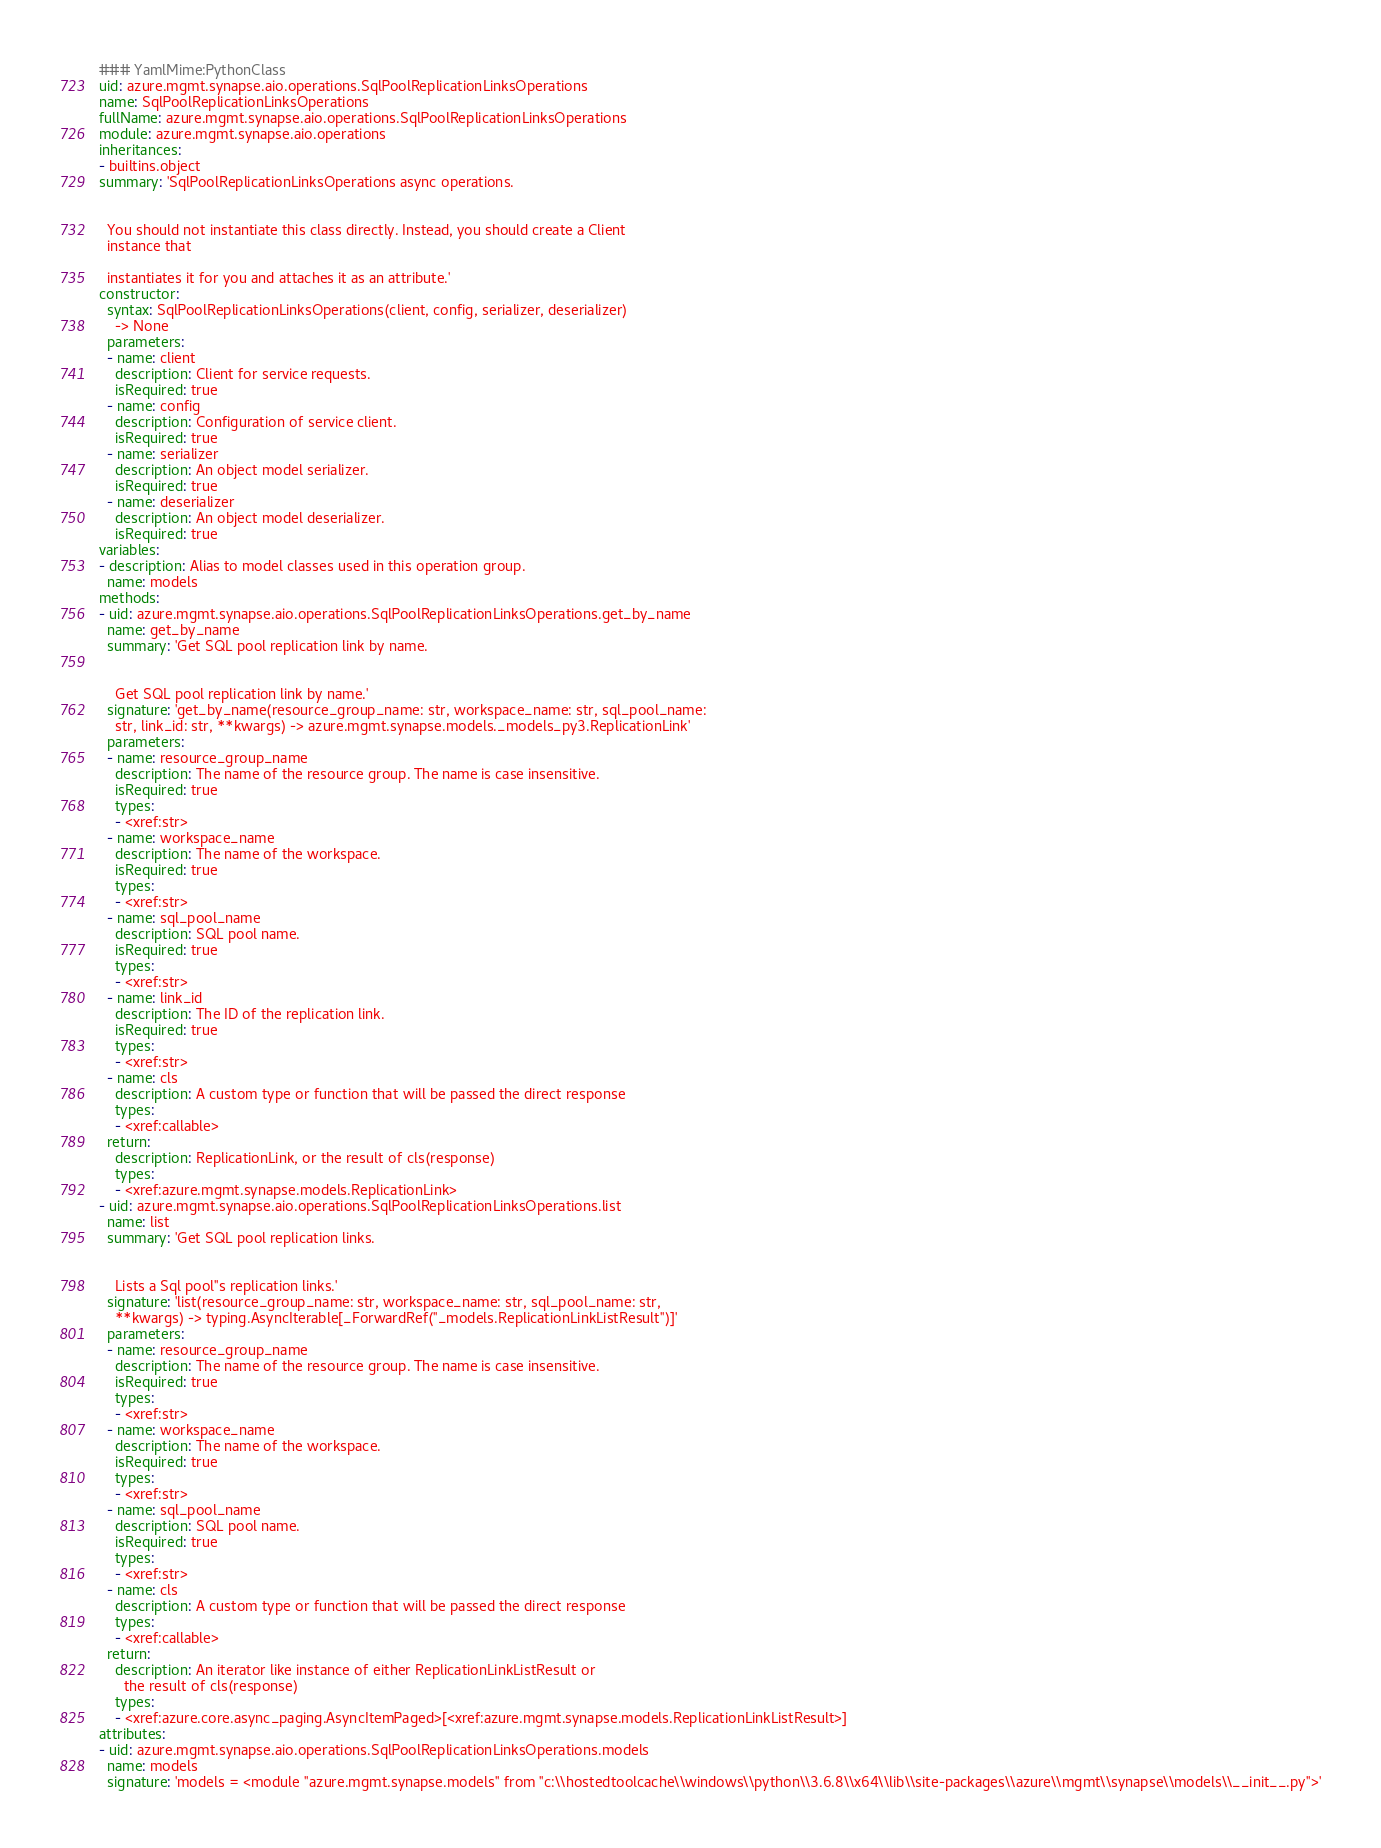<code> <loc_0><loc_0><loc_500><loc_500><_YAML_>### YamlMime:PythonClass
uid: azure.mgmt.synapse.aio.operations.SqlPoolReplicationLinksOperations
name: SqlPoolReplicationLinksOperations
fullName: azure.mgmt.synapse.aio.operations.SqlPoolReplicationLinksOperations
module: azure.mgmt.synapse.aio.operations
inheritances:
- builtins.object
summary: 'SqlPoolReplicationLinksOperations async operations.


  You should not instantiate this class directly. Instead, you should create a Client
  instance that

  instantiates it for you and attaches it as an attribute.'
constructor:
  syntax: SqlPoolReplicationLinksOperations(client, config, serializer, deserializer)
    -> None
  parameters:
  - name: client
    description: Client for service requests.
    isRequired: true
  - name: config
    description: Configuration of service client.
    isRequired: true
  - name: serializer
    description: An object model serializer.
    isRequired: true
  - name: deserializer
    description: An object model deserializer.
    isRequired: true
variables:
- description: Alias to model classes used in this operation group.
  name: models
methods:
- uid: azure.mgmt.synapse.aio.operations.SqlPoolReplicationLinksOperations.get_by_name
  name: get_by_name
  summary: 'Get SQL pool replication link by name.


    Get SQL pool replication link by name.'
  signature: 'get_by_name(resource_group_name: str, workspace_name: str, sql_pool_name:
    str, link_id: str, **kwargs) -> azure.mgmt.synapse.models._models_py3.ReplicationLink'
  parameters:
  - name: resource_group_name
    description: The name of the resource group. The name is case insensitive.
    isRequired: true
    types:
    - <xref:str>
  - name: workspace_name
    description: The name of the workspace.
    isRequired: true
    types:
    - <xref:str>
  - name: sql_pool_name
    description: SQL pool name.
    isRequired: true
    types:
    - <xref:str>
  - name: link_id
    description: The ID of the replication link.
    isRequired: true
    types:
    - <xref:str>
  - name: cls
    description: A custom type or function that will be passed the direct response
    types:
    - <xref:callable>
  return:
    description: ReplicationLink, or the result of cls(response)
    types:
    - <xref:azure.mgmt.synapse.models.ReplicationLink>
- uid: azure.mgmt.synapse.aio.operations.SqlPoolReplicationLinksOperations.list
  name: list
  summary: 'Get SQL pool replication links.


    Lists a Sql pool''s replication links.'
  signature: 'list(resource_group_name: str, workspace_name: str, sql_pool_name: str,
    **kwargs) -> typing.AsyncIterable[_ForwardRef(''_models.ReplicationLinkListResult'')]'
  parameters:
  - name: resource_group_name
    description: The name of the resource group. The name is case insensitive.
    isRequired: true
    types:
    - <xref:str>
  - name: workspace_name
    description: The name of the workspace.
    isRequired: true
    types:
    - <xref:str>
  - name: sql_pool_name
    description: SQL pool name.
    isRequired: true
    types:
    - <xref:str>
  - name: cls
    description: A custom type or function that will be passed the direct response
    types:
    - <xref:callable>
  return:
    description: An iterator like instance of either ReplicationLinkListResult or
      the result of cls(response)
    types:
    - <xref:azure.core.async_paging.AsyncItemPaged>[<xref:azure.mgmt.synapse.models.ReplicationLinkListResult>]
attributes:
- uid: azure.mgmt.synapse.aio.operations.SqlPoolReplicationLinksOperations.models
  name: models
  signature: 'models = <module ''azure.mgmt.synapse.models'' from ''c:\\hostedtoolcache\\windows\\python\\3.6.8\\x64\\lib\\site-packages\\azure\\mgmt\\synapse\\models\\__init__.py''>'
</code> 